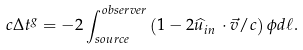<formula> <loc_0><loc_0><loc_500><loc_500>c \Delta t ^ { g } = - 2 \int _ { s o u r c e } ^ { o b s e r v e r } \left ( 1 - 2 \widehat { u } _ { i n } \, \cdot \vec { v } / c \right ) \phi d \ell .</formula> 